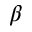<formula> <loc_0><loc_0><loc_500><loc_500>\beta</formula> 